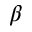<formula> <loc_0><loc_0><loc_500><loc_500>\beta</formula> 